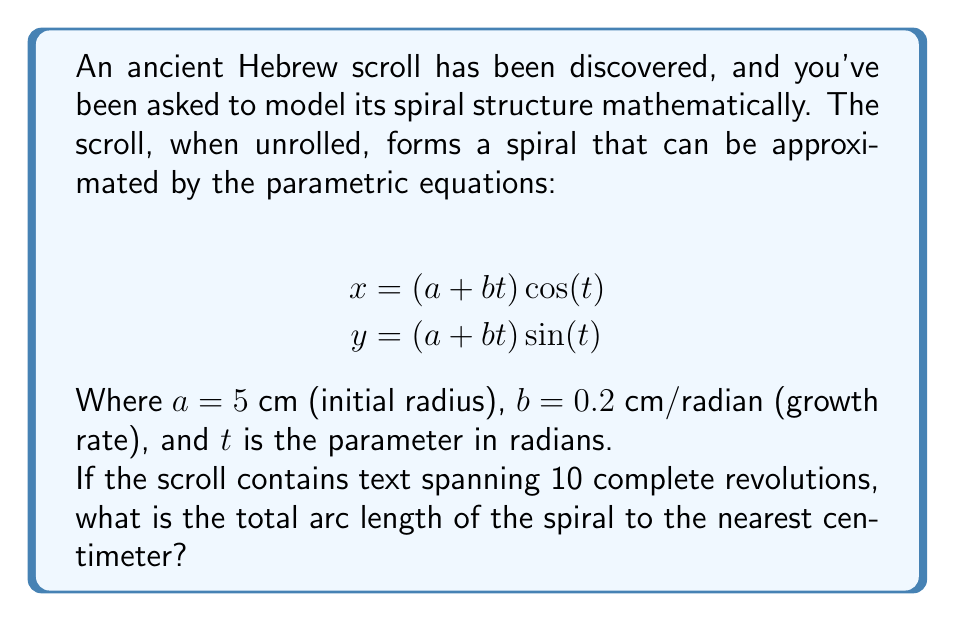What is the answer to this math problem? To solve this problem, we'll follow these steps:

1) The arc length of a parametric curve is given by the formula:

   $$L = \int_{t_1}^{t_2} \sqrt{\left(\frac{dx}{dt}\right)^2 + \left(\frac{dy}{dt}\right)^2} dt$$

2) We need to find $\frac{dx}{dt}$ and $\frac{dy}{dt}$:

   $$\frac{dx}{dt} = b\cos(t) - (a+bt)\sin(t)$$
   $$\frac{dy}{dt} = b\sin(t) + (a+bt)\cos(t)$$

3) Substituting these into the arc length formula:

   $$L = \int_{t_1}^{t_2} \sqrt{(b\cos(t) - (a+bt)\sin(t))^2 + (b\sin(t) + (a+bt)\cos(t))^2} dt$$

4) Simplifying the expression under the square root:

   $$L = \int_{t_1}^{t_2} \sqrt{b^2 + (a+bt)^2} dt$$

5) For 10 complete revolutions, $t$ goes from 0 to $20\pi$ radians:

   $$L = \int_{0}^{20\pi} \sqrt{0.2^2 + (5+0.2t)^2} dt$$

6) This integral doesn't have a simple analytical solution, so we'll use numerical integration. Using a computer algebra system or numerical integration tool, we get:

   $$L \approx 691.77 \text{ cm}$$

7) Rounding to the nearest centimeter:

   $$L \approx 692 \text{ cm}$$

This result represents the total length of the spiral path formed by the unrolled scroll.
Answer: 692 cm 